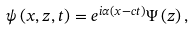Convert formula to latex. <formula><loc_0><loc_0><loc_500><loc_500>\psi \left ( x , z , t \right ) = e ^ { i \alpha \left ( x - c t \right ) } \Psi \left ( z \right ) ,</formula> 